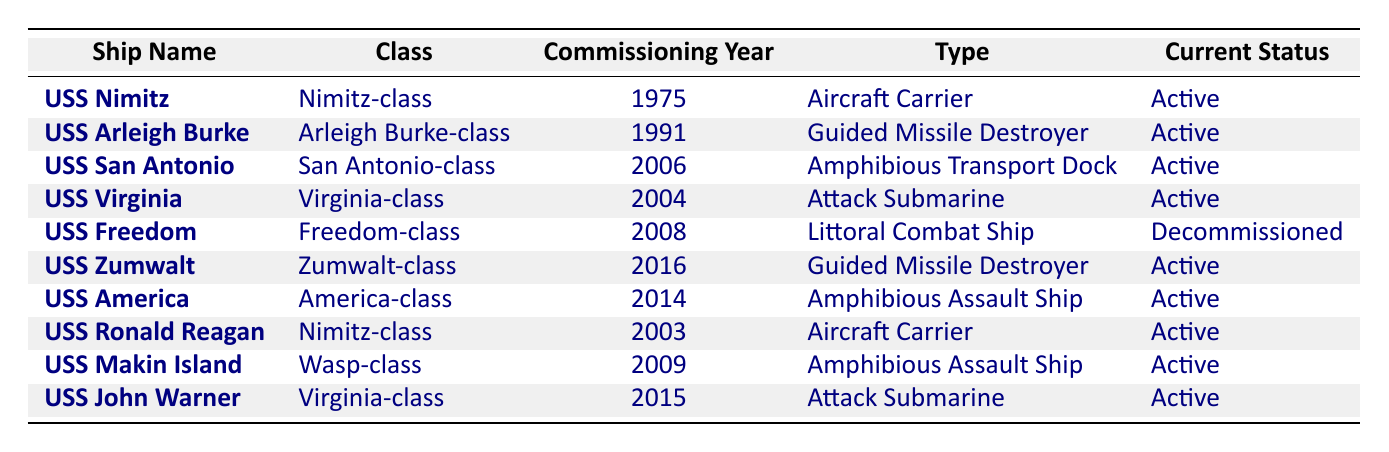What's the name of the first ship commissioned during my service years? The table lists the commissioning years of the ships. The earliest year listed is 1975, which corresponds to the USS Nimitz.
Answer: USS Nimitz How many ships are currently active? By looking through the "Current Status" column, I see that most ships are listed as "Active." Counting these gives me 8 active ships out of the 10 listed.
Answer: 8 Which class does the USS John Warner belong to? In the table, I look for the "Ship Name" that matches "USS John Warner." The corresponding class listed in that row is "Virginia-class."
Answer: Virginia-class Are there any decommissioned ships in the list? I check the "Current Status" column for any indication of decommissioned ships. The USS Freedom is marked as "Decommissioned." Thus, the answer is yes.
Answer: Yes What is the average commissioning year of active ships? First, I note the commissioning years of all active ships: 1975, 1991, 2006, 2004, 2003, 2009, 2014, and 2015. I add these years: 1975 + 1991 + 2006 + 2004 + 2003 + 2009 + 2014 + 2015 = 1598. Then, I divide by the number of active ships: 1598 / 8 = 199.75, which rounds to 200.
Answer: 200 How many ships were commissioned after the year 2000? I analyze the "Commissioning Year" column and count all ships with a commissioning year greater than 2000, which gives me five ships: USS San Antonio (2006), USS Virginia (2004), USS Freedom (2008), USS America (2014), and USS John Warner (2015).
Answer: 5 What type of ship is the USS Zumwalt? Looking at the row for "USS Zumwalt," I see that it is classified as a "Guided Missile Destroyer."
Answer: Guided Missile Destroyer Which class has the most ships currently in active status? I identify the number of active ships in each class: Nimitz-class has 2 (USS Nimitz, USS Ronald Reagan), Virginia-class has 2 (USS Virginia and USS John Warner), and others have 1 each. The highest count is 2 ships for both Nimitz-class and Virginia-class.
Answer: Nimitz-class and Virginia-class Is the USS Freedom still active? Referring to the "Current Status" column of the USS Freedom, I observe that it is listed as "Decommissioned," so the answer is no.
Answer: No 